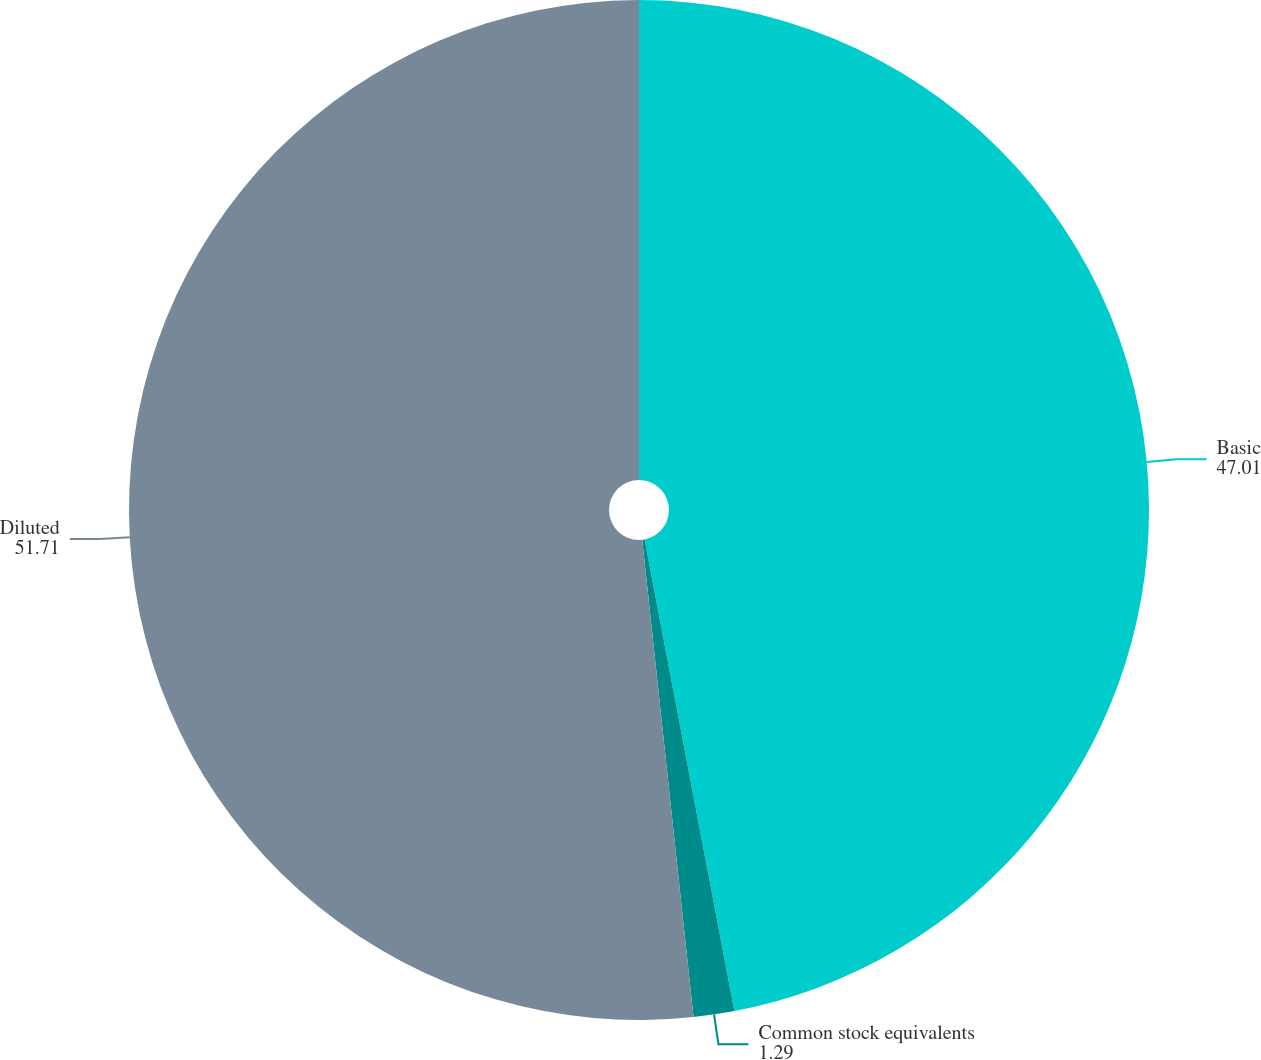<chart> <loc_0><loc_0><loc_500><loc_500><pie_chart><fcel>Basic<fcel>Common stock equivalents<fcel>Diluted<nl><fcel>47.01%<fcel>1.29%<fcel>51.71%<nl></chart> 